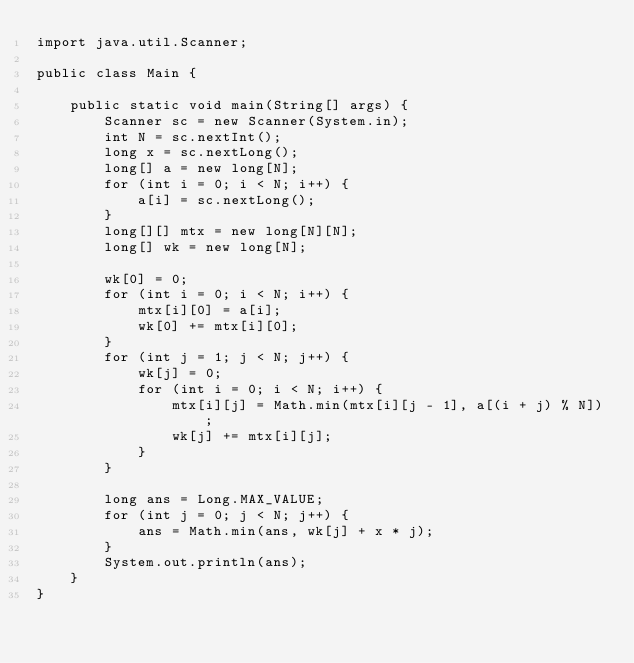Convert code to text. <code><loc_0><loc_0><loc_500><loc_500><_Java_>import java.util.Scanner;

public class Main {

	public static void main(String[] args) {
		Scanner sc = new Scanner(System.in);
		int N = sc.nextInt();
		long x = sc.nextLong();
		long[] a = new long[N];
		for (int i = 0; i < N; i++) {
			a[i] = sc.nextLong();
		}
		long[][] mtx = new long[N][N];
		long[] wk = new long[N];

		wk[0] = 0;
		for (int i = 0; i < N; i++) {
			mtx[i][0] = a[i];
			wk[0] += mtx[i][0];
		}
		for (int j = 1; j < N; j++) {
			wk[j] = 0;
			for (int i = 0; i < N; i++) {
				mtx[i][j] = Math.min(mtx[i][j - 1], a[(i + j) % N]);
				wk[j] += mtx[i][j];
			}
		}

		long ans = Long.MAX_VALUE;
		for (int j = 0; j < N; j++) {
			ans = Math.min(ans, wk[j] + x * j);
		}
		System.out.println(ans);
	}
}
</code> 